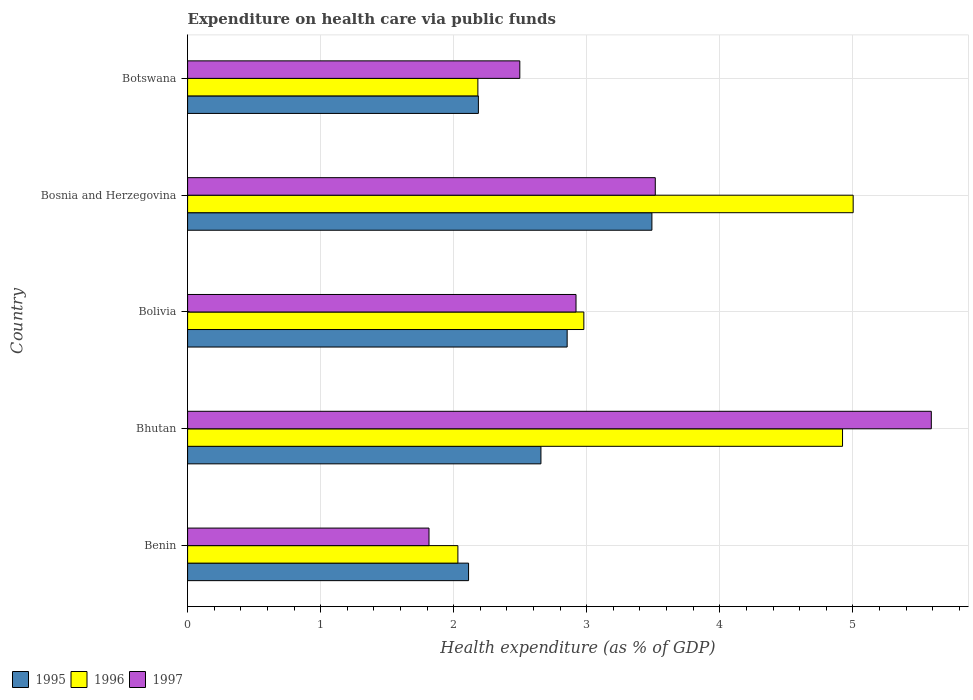Are the number of bars per tick equal to the number of legend labels?
Your answer should be compact. Yes. How many bars are there on the 2nd tick from the top?
Provide a succinct answer. 3. In how many cases, is the number of bars for a given country not equal to the number of legend labels?
Keep it short and to the point. 0. What is the expenditure made on health care in 1997 in Bolivia?
Provide a short and direct response. 2.92. Across all countries, what is the maximum expenditure made on health care in 1995?
Make the answer very short. 3.49. Across all countries, what is the minimum expenditure made on health care in 1996?
Your answer should be very brief. 2.03. In which country was the expenditure made on health care in 1996 maximum?
Provide a short and direct response. Bosnia and Herzegovina. In which country was the expenditure made on health care in 1996 minimum?
Offer a very short reply. Benin. What is the total expenditure made on health care in 1995 in the graph?
Offer a terse response. 13.3. What is the difference between the expenditure made on health care in 1995 in Bhutan and that in Botswana?
Ensure brevity in your answer.  0.47. What is the difference between the expenditure made on health care in 1995 in Bolivia and the expenditure made on health care in 1996 in Benin?
Offer a very short reply. 0.82. What is the average expenditure made on health care in 1995 per country?
Offer a very short reply. 2.66. What is the difference between the expenditure made on health care in 1995 and expenditure made on health care in 1996 in Benin?
Your response must be concise. 0.08. In how many countries, is the expenditure made on health care in 1995 greater than 0.8 %?
Your answer should be compact. 5. What is the ratio of the expenditure made on health care in 1997 in Benin to that in Bolivia?
Provide a succinct answer. 0.62. Is the expenditure made on health care in 1997 in Bolivia less than that in Bosnia and Herzegovina?
Provide a short and direct response. Yes. What is the difference between the highest and the second highest expenditure made on health care in 1997?
Offer a very short reply. 2.07. What is the difference between the highest and the lowest expenditure made on health care in 1996?
Provide a succinct answer. 2.97. What does the 3rd bar from the bottom in Bhutan represents?
Keep it short and to the point. 1997. Does the graph contain any zero values?
Make the answer very short. No. Where does the legend appear in the graph?
Your answer should be compact. Bottom left. How many legend labels are there?
Offer a very short reply. 3. How are the legend labels stacked?
Offer a very short reply. Horizontal. What is the title of the graph?
Provide a succinct answer. Expenditure on health care via public funds. What is the label or title of the X-axis?
Provide a succinct answer. Health expenditure (as % of GDP). What is the label or title of the Y-axis?
Your answer should be compact. Country. What is the Health expenditure (as % of GDP) of 1995 in Benin?
Give a very brief answer. 2.11. What is the Health expenditure (as % of GDP) in 1996 in Benin?
Provide a short and direct response. 2.03. What is the Health expenditure (as % of GDP) in 1997 in Benin?
Your answer should be very brief. 1.81. What is the Health expenditure (as % of GDP) of 1995 in Bhutan?
Your answer should be very brief. 2.66. What is the Health expenditure (as % of GDP) in 1996 in Bhutan?
Provide a short and direct response. 4.92. What is the Health expenditure (as % of GDP) of 1997 in Bhutan?
Provide a succinct answer. 5.59. What is the Health expenditure (as % of GDP) in 1995 in Bolivia?
Offer a terse response. 2.85. What is the Health expenditure (as % of GDP) in 1996 in Bolivia?
Your response must be concise. 2.98. What is the Health expenditure (as % of GDP) in 1997 in Bolivia?
Provide a short and direct response. 2.92. What is the Health expenditure (as % of GDP) in 1995 in Bosnia and Herzegovina?
Keep it short and to the point. 3.49. What is the Health expenditure (as % of GDP) of 1996 in Bosnia and Herzegovina?
Your answer should be very brief. 5. What is the Health expenditure (as % of GDP) in 1997 in Bosnia and Herzegovina?
Make the answer very short. 3.52. What is the Health expenditure (as % of GDP) in 1995 in Botswana?
Keep it short and to the point. 2.19. What is the Health expenditure (as % of GDP) of 1996 in Botswana?
Give a very brief answer. 2.18. What is the Health expenditure (as % of GDP) in 1997 in Botswana?
Ensure brevity in your answer.  2.5. Across all countries, what is the maximum Health expenditure (as % of GDP) of 1995?
Keep it short and to the point. 3.49. Across all countries, what is the maximum Health expenditure (as % of GDP) in 1996?
Keep it short and to the point. 5. Across all countries, what is the maximum Health expenditure (as % of GDP) of 1997?
Ensure brevity in your answer.  5.59. Across all countries, what is the minimum Health expenditure (as % of GDP) of 1995?
Provide a succinct answer. 2.11. Across all countries, what is the minimum Health expenditure (as % of GDP) of 1996?
Provide a succinct answer. 2.03. Across all countries, what is the minimum Health expenditure (as % of GDP) of 1997?
Your answer should be compact. 1.81. What is the total Health expenditure (as % of GDP) in 1995 in the graph?
Keep it short and to the point. 13.3. What is the total Health expenditure (as % of GDP) of 1996 in the graph?
Your answer should be very brief. 17.12. What is the total Health expenditure (as % of GDP) in 1997 in the graph?
Give a very brief answer. 16.34. What is the difference between the Health expenditure (as % of GDP) in 1995 in Benin and that in Bhutan?
Your answer should be compact. -0.54. What is the difference between the Health expenditure (as % of GDP) in 1996 in Benin and that in Bhutan?
Ensure brevity in your answer.  -2.89. What is the difference between the Health expenditure (as % of GDP) of 1997 in Benin and that in Bhutan?
Provide a short and direct response. -3.78. What is the difference between the Health expenditure (as % of GDP) of 1995 in Benin and that in Bolivia?
Your answer should be compact. -0.74. What is the difference between the Health expenditure (as % of GDP) of 1996 in Benin and that in Bolivia?
Your response must be concise. -0.95. What is the difference between the Health expenditure (as % of GDP) in 1997 in Benin and that in Bolivia?
Ensure brevity in your answer.  -1.1. What is the difference between the Health expenditure (as % of GDP) of 1995 in Benin and that in Bosnia and Herzegovina?
Keep it short and to the point. -1.38. What is the difference between the Health expenditure (as % of GDP) of 1996 in Benin and that in Bosnia and Herzegovina?
Your answer should be compact. -2.97. What is the difference between the Health expenditure (as % of GDP) in 1997 in Benin and that in Bosnia and Herzegovina?
Keep it short and to the point. -1.7. What is the difference between the Health expenditure (as % of GDP) in 1995 in Benin and that in Botswana?
Ensure brevity in your answer.  -0.07. What is the difference between the Health expenditure (as % of GDP) in 1996 in Benin and that in Botswana?
Provide a short and direct response. -0.15. What is the difference between the Health expenditure (as % of GDP) of 1997 in Benin and that in Botswana?
Give a very brief answer. -0.68. What is the difference between the Health expenditure (as % of GDP) of 1995 in Bhutan and that in Bolivia?
Give a very brief answer. -0.2. What is the difference between the Health expenditure (as % of GDP) of 1996 in Bhutan and that in Bolivia?
Provide a short and direct response. 1.94. What is the difference between the Health expenditure (as % of GDP) of 1997 in Bhutan and that in Bolivia?
Keep it short and to the point. 2.67. What is the difference between the Health expenditure (as % of GDP) in 1995 in Bhutan and that in Bosnia and Herzegovina?
Offer a terse response. -0.83. What is the difference between the Health expenditure (as % of GDP) in 1996 in Bhutan and that in Bosnia and Herzegovina?
Your response must be concise. -0.08. What is the difference between the Health expenditure (as % of GDP) of 1997 in Bhutan and that in Bosnia and Herzegovina?
Keep it short and to the point. 2.07. What is the difference between the Health expenditure (as % of GDP) of 1995 in Bhutan and that in Botswana?
Offer a terse response. 0.47. What is the difference between the Health expenditure (as % of GDP) in 1996 in Bhutan and that in Botswana?
Offer a very short reply. 2.74. What is the difference between the Health expenditure (as % of GDP) in 1997 in Bhutan and that in Botswana?
Make the answer very short. 3.09. What is the difference between the Health expenditure (as % of GDP) in 1995 in Bolivia and that in Bosnia and Herzegovina?
Your response must be concise. -0.64. What is the difference between the Health expenditure (as % of GDP) of 1996 in Bolivia and that in Bosnia and Herzegovina?
Your answer should be compact. -2.02. What is the difference between the Health expenditure (as % of GDP) of 1997 in Bolivia and that in Bosnia and Herzegovina?
Your answer should be very brief. -0.6. What is the difference between the Health expenditure (as % of GDP) in 1995 in Bolivia and that in Botswana?
Your answer should be very brief. 0.67. What is the difference between the Health expenditure (as % of GDP) in 1996 in Bolivia and that in Botswana?
Your response must be concise. 0.8. What is the difference between the Health expenditure (as % of GDP) in 1997 in Bolivia and that in Botswana?
Your response must be concise. 0.42. What is the difference between the Health expenditure (as % of GDP) of 1995 in Bosnia and Herzegovina and that in Botswana?
Your answer should be very brief. 1.3. What is the difference between the Health expenditure (as % of GDP) of 1996 in Bosnia and Herzegovina and that in Botswana?
Your response must be concise. 2.82. What is the difference between the Health expenditure (as % of GDP) of 1997 in Bosnia and Herzegovina and that in Botswana?
Your answer should be very brief. 1.02. What is the difference between the Health expenditure (as % of GDP) in 1995 in Benin and the Health expenditure (as % of GDP) in 1996 in Bhutan?
Provide a short and direct response. -2.81. What is the difference between the Health expenditure (as % of GDP) in 1995 in Benin and the Health expenditure (as % of GDP) in 1997 in Bhutan?
Provide a short and direct response. -3.48. What is the difference between the Health expenditure (as % of GDP) of 1996 in Benin and the Health expenditure (as % of GDP) of 1997 in Bhutan?
Give a very brief answer. -3.56. What is the difference between the Health expenditure (as % of GDP) of 1995 in Benin and the Health expenditure (as % of GDP) of 1996 in Bolivia?
Give a very brief answer. -0.87. What is the difference between the Health expenditure (as % of GDP) of 1995 in Benin and the Health expenditure (as % of GDP) of 1997 in Bolivia?
Offer a very short reply. -0.81. What is the difference between the Health expenditure (as % of GDP) of 1996 in Benin and the Health expenditure (as % of GDP) of 1997 in Bolivia?
Ensure brevity in your answer.  -0.89. What is the difference between the Health expenditure (as % of GDP) of 1995 in Benin and the Health expenditure (as % of GDP) of 1996 in Bosnia and Herzegovina?
Provide a succinct answer. -2.89. What is the difference between the Health expenditure (as % of GDP) of 1995 in Benin and the Health expenditure (as % of GDP) of 1997 in Bosnia and Herzegovina?
Ensure brevity in your answer.  -1.4. What is the difference between the Health expenditure (as % of GDP) in 1996 in Benin and the Health expenditure (as % of GDP) in 1997 in Bosnia and Herzegovina?
Your answer should be compact. -1.48. What is the difference between the Health expenditure (as % of GDP) of 1995 in Benin and the Health expenditure (as % of GDP) of 1996 in Botswana?
Offer a very short reply. -0.07. What is the difference between the Health expenditure (as % of GDP) of 1995 in Benin and the Health expenditure (as % of GDP) of 1997 in Botswana?
Ensure brevity in your answer.  -0.39. What is the difference between the Health expenditure (as % of GDP) of 1996 in Benin and the Health expenditure (as % of GDP) of 1997 in Botswana?
Your answer should be compact. -0.47. What is the difference between the Health expenditure (as % of GDP) in 1995 in Bhutan and the Health expenditure (as % of GDP) in 1996 in Bolivia?
Make the answer very short. -0.32. What is the difference between the Health expenditure (as % of GDP) of 1995 in Bhutan and the Health expenditure (as % of GDP) of 1997 in Bolivia?
Your response must be concise. -0.26. What is the difference between the Health expenditure (as % of GDP) in 1996 in Bhutan and the Health expenditure (as % of GDP) in 1997 in Bolivia?
Ensure brevity in your answer.  2. What is the difference between the Health expenditure (as % of GDP) of 1995 in Bhutan and the Health expenditure (as % of GDP) of 1996 in Bosnia and Herzegovina?
Your answer should be compact. -2.35. What is the difference between the Health expenditure (as % of GDP) in 1995 in Bhutan and the Health expenditure (as % of GDP) in 1997 in Bosnia and Herzegovina?
Provide a succinct answer. -0.86. What is the difference between the Health expenditure (as % of GDP) in 1996 in Bhutan and the Health expenditure (as % of GDP) in 1997 in Bosnia and Herzegovina?
Offer a very short reply. 1.41. What is the difference between the Health expenditure (as % of GDP) of 1995 in Bhutan and the Health expenditure (as % of GDP) of 1996 in Botswana?
Your answer should be compact. 0.47. What is the difference between the Health expenditure (as % of GDP) in 1995 in Bhutan and the Health expenditure (as % of GDP) in 1997 in Botswana?
Provide a succinct answer. 0.16. What is the difference between the Health expenditure (as % of GDP) in 1996 in Bhutan and the Health expenditure (as % of GDP) in 1997 in Botswana?
Your answer should be compact. 2.43. What is the difference between the Health expenditure (as % of GDP) of 1995 in Bolivia and the Health expenditure (as % of GDP) of 1996 in Bosnia and Herzegovina?
Offer a very short reply. -2.15. What is the difference between the Health expenditure (as % of GDP) in 1995 in Bolivia and the Health expenditure (as % of GDP) in 1997 in Bosnia and Herzegovina?
Your answer should be very brief. -0.66. What is the difference between the Health expenditure (as % of GDP) in 1996 in Bolivia and the Health expenditure (as % of GDP) in 1997 in Bosnia and Herzegovina?
Your response must be concise. -0.54. What is the difference between the Health expenditure (as % of GDP) of 1995 in Bolivia and the Health expenditure (as % of GDP) of 1996 in Botswana?
Your answer should be compact. 0.67. What is the difference between the Health expenditure (as % of GDP) in 1995 in Bolivia and the Health expenditure (as % of GDP) in 1997 in Botswana?
Offer a terse response. 0.36. What is the difference between the Health expenditure (as % of GDP) in 1996 in Bolivia and the Health expenditure (as % of GDP) in 1997 in Botswana?
Provide a succinct answer. 0.48. What is the difference between the Health expenditure (as % of GDP) of 1995 in Bosnia and Herzegovina and the Health expenditure (as % of GDP) of 1996 in Botswana?
Provide a short and direct response. 1.31. What is the difference between the Health expenditure (as % of GDP) in 1996 in Bosnia and Herzegovina and the Health expenditure (as % of GDP) in 1997 in Botswana?
Ensure brevity in your answer.  2.51. What is the average Health expenditure (as % of GDP) of 1995 per country?
Your response must be concise. 2.66. What is the average Health expenditure (as % of GDP) in 1996 per country?
Provide a succinct answer. 3.42. What is the average Health expenditure (as % of GDP) in 1997 per country?
Offer a very short reply. 3.27. What is the difference between the Health expenditure (as % of GDP) of 1995 and Health expenditure (as % of GDP) of 1996 in Benin?
Offer a very short reply. 0.08. What is the difference between the Health expenditure (as % of GDP) in 1995 and Health expenditure (as % of GDP) in 1997 in Benin?
Your answer should be very brief. 0.3. What is the difference between the Health expenditure (as % of GDP) in 1996 and Health expenditure (as % of GDP) in 1997 in Benin?
Ensure brevity in your answer.  0.22. What is the difference between the Health expenditure (as % of GDP) in 1995 and Health expenditure (as % of GDP) in 1996 in Bhutan?
Ensure brevity in your answer.  -2.27. What is the difference between the Health expenditure (as % of GDP) in 1995 and Health expenditure (as % of GDP) in 1997 in Bhutan?
Ensure brevity in your answer.  -2.93. What is the difference between the Health expenditure (as % of GDP) in 1996 and Health expenditure (as % of GDP) in 1997 in Bhutan?
Provide a short and direct response. -0.67. What is the difference between the Health expenditure (as % of GDP) in 1995 and Health expenditure (as % of GDP) in 1996 in Bolivia?
Your answer should be compact. -0.13. What is the difference between the Health expenditure (as % of GDP) in 1995 and Health expenditure (as % of GDP) in 1997 in Bolivia?
Provide a succinct answer. -0.07. What is the difference between the Health expenditure (as % of GDP) in 1996 and Health expenditure (as % of GDP) in 1997 in Bolivia?
Make the answer very short. 0.06. What is the difference between the Health expenditure (as % of GDP) in 1995 and Health expenditure (as % of GDP) in 1996 in Bosnia and Herzegovina?
Provide a short and direct response. -1.51. What is the difference between the Health expenditure (as % of GDP) in 1995 and Health expenditure (as % of GDP) in 1997 in Bosnia and Herzegovina?
Provide a short and direct response. -0.03. What is the difference between the Health expenditure (as % of GDP) of 1996 and Health expenditure (as % of GDP) of 1997 in Bosnia and Herzegovina?
Give a very brief answer. 1.49. What is the difference between the Health expenditure (as % of GDP) in 1995 and Health expenditure (as % of GDP) in 1996 in Botswana?
Give a very brief answer. 0. What is the difference between the Health expenditure (as % of GDP) in 1995 and Health expenditure (as % of GDP) in 1997 in Botswana?
Make the answer very short. -0.31. What is the difference between the Health expenditure (as % of GDP) in 1996 and Health expenditure (as % of GDP) in 1997 in Botswana?
Your answer should be compact. -0.32. What is the ratio of the Health expenditure (as % of GDP) of 1995 in Benin to that in Bhutan?
Your answer should be compact. 0.8. What is the ratio of the Health expenditure (as % of GDP) in 1996 in Benin to that in Bhutan?
Make the answer very short. 0.41. What is the ratio of the Health expenditure (as % of GDP) in 1997 in Benin to that in Bhutan?
Ensure brevity in your answer.  0.32. What is the ratio of the Health expenditure (as % of GDP) in 1995 in Benin to that in Bolivia?
Keep it short and to the point. 0.74. What is the ratio of the Health expenditure (as % of GDP) in 1996 in Benin to that in Bolivia?
Your answer should be compact. 0.68. What is the ratio of the Health expenditure (as % of GDP) of 1997 in Benin to that in Bolivia?
Ensure brevity in your answer.  0.62. What is the ratio of the Health expenditure (as % of GDP) of 1995 in Benin to that in Bosnia and Herzegovina?
Provide a succinct answer. 0.61. What is the ratio of the Health expenditure (as % of GDP) in 1996 in Benin to that in Bosnia and Herzegovina?
Offer a terse response. 0.41. What is the ratio of the Health expenditure (as % of GDP) in 1997 in Benin to that in Bosnia and Herzegovina?
Provide a short and direct response. 0.52. What is the ratio of the Health expenditure (as % of GDP) in 1995 in Benin to that in Botswana?
Your answer should be very brief. 0.97. What is the ratio of the Health expenditure (as % of GDP) of 1996 in Benin to that in Botswana?
Offer a very short reply. 0.93. What is the ratio of the Health expenditure (as % of GDP) in 1997 in Benin to that in Botswana?
Ensure brevity in your answer.  0.73. What is the ratio of the Health expenditure (as % of GDP) of 1995 in Bhutan to that in Bolivia?
Give a very brief answer. 0.93. What is the ratio of the Health expenditure (as % of GDP) in 1996 in Bhutan to that in Bolivia?
Ensure brevity in your answer.  1.65. What is the ratio of the Health expenditure (as % of GDP) of 1997 in Bhutan to that in Bolivia?
Provide a succinct answer. 1.91. What is the ratio of the Health expenditure (as % of GDP) in 1995 in Bhutan to that in Bosnia and Herzegovina?
Provide a succinct answer. 0.76. What is the ratio of the Health expenditure (as % of GDP) of 1996 in Bhutan to that in Bosnia and Herzegovina?
Provide a short and direct response. 0.98. What is the ratio of the Health expenditure (as % of GDP) in 1997 in Bhutan to that in Bosnia and Herzegovina?
Your answer should be very brief. 1.59. What is the ratio of the Health expenditure (as % of GDP) in 1995 in Bhutan to that in Botswana?
Provide a short and direct response. 1.22. What is the ratio of the Health expenditure (as % of GDP) of 1996 in Bhutan to that in Botswana?
Provide a succinct answer. 2.26. What is the ratio of the Health expenditure (as % of GDP) of 1997 in Bhutan to that in Botswana?
Provide a short and direct response. 2.24. What is the ratio of the Health expenditure (as % of GDP) of 1995 in Bolivia to that in Bosnia and Herzegovina?
Ensure brevity in your answer.  0.82. What is the ratio of the Health expenditure (as % of GDP) in 1996 in Bolivia to that in Bosnia and Herzegovina?
Offer a terse response. 0.6. What is the ratio of the Health expenditure (as % of GDP) in 1997 in Bolivia to that in Bosnia and Herzegovina?
Keep it short and to the point. 0.83. What is the ratio of the Health expenditure (as % of GDP) in 1995 in Bolivia to that in Botswana?
Provide a succinct answer. 1.31. What is the ratio of the Health expenditure (as % of GDP) in 1996 in Bolivia to that in Botswana?
Offer a very short reply. 1.37. What is the ratio of the Health expenditure (as % of GDP) in 1997 in Bolivia to that in Botswana?
Offer a very short reply. 1.17. What is the ratio of the Health expenditure (as % of GDP) of 1995 in Bosnia and Herzegovina to that in Botswana?
Your response must be concise. 1.6. What is the ratio of the Health expenditure (as % of GDP) of 1996 in Bosnia and Herzegovina to that in Botswana?
Offer a very short reply. 2.29. What is the ratio of the Health expenditure (as % of GDP) of 1997 in Bosnia and Herzegovina to that in Botswana?
Your answer should be very brief. 1.41. What is the difference between the highest and the second highest Health expenditure (as % of GDP) of 1995?
Ensure brevity in your answer.  0.64. What is the difference between the highest and the second highest Health expenditure (as % of GDP) of 1997?
Offer a very short reply. 2.07. What is the difference between the highest and the lowest Health expenditure (as % of GDP) of 1995?
Keep it short and to the point. 1.38. What is the difference between the highest and the lowest Health expenditure (as % of GDP) of 1996?
Your response must be concise. 2.97. What is the difference between the highest and the lowest Health expenditure (as % of GDP) in 1997?
Make the answer very short. 3.78. 